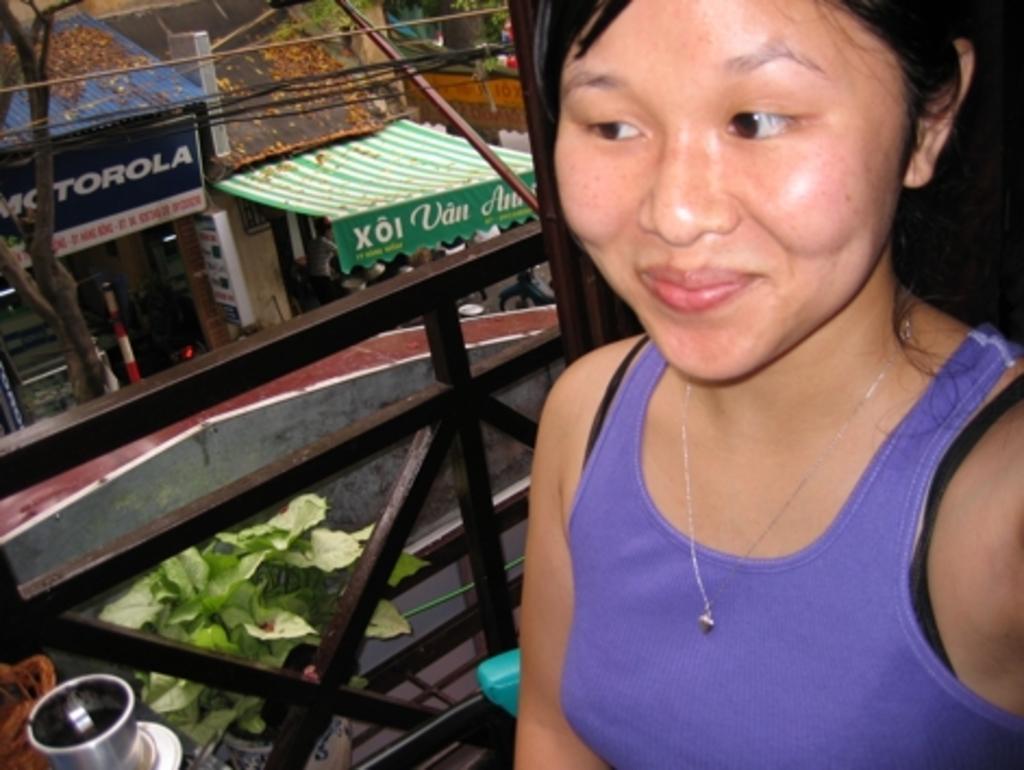Describe this image in one or two sentences. In this picture we see a woman looking and smiling at someone. In the background, we see many shops and trees. 